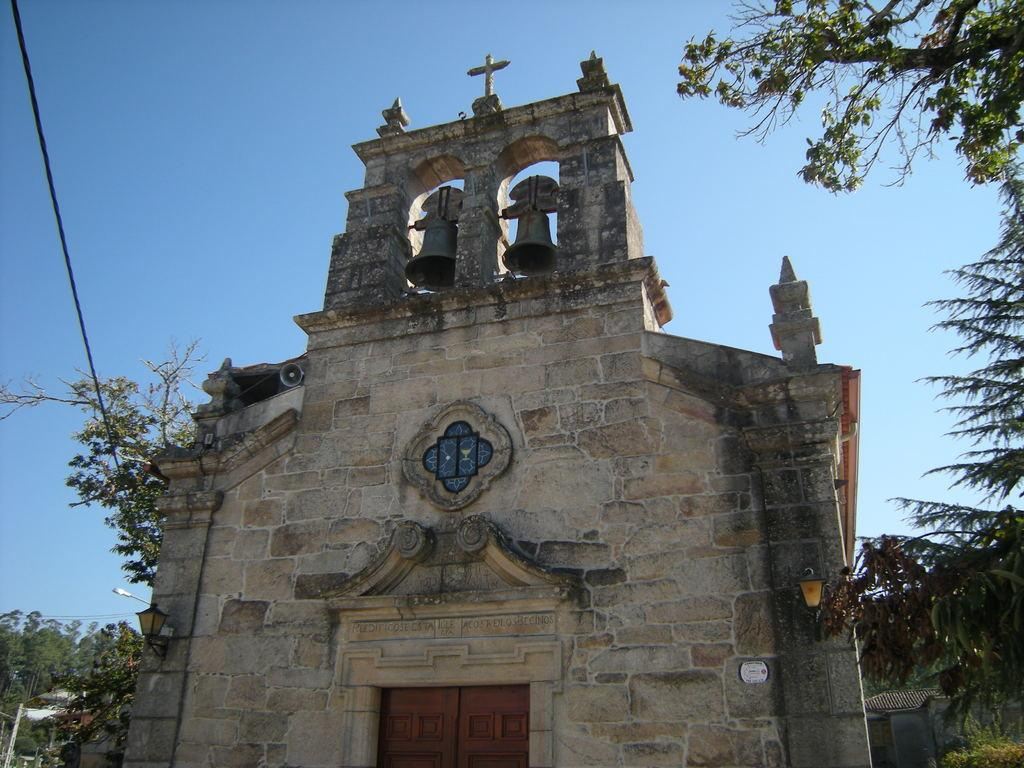What type of building is in the image? There is a church in the image. What can be seen at the top of the church? There are two bells at the top of the church. What is located on the left side of the image? There are trees on the left side of the image. What is visible in the background of the image? There are trees and the sky visible in the background of the image. What type of curtain can be seen hanging in the church in the image? There is no curtain visible in the image; it is a picture of a church with bells at the top and trees in the background. 